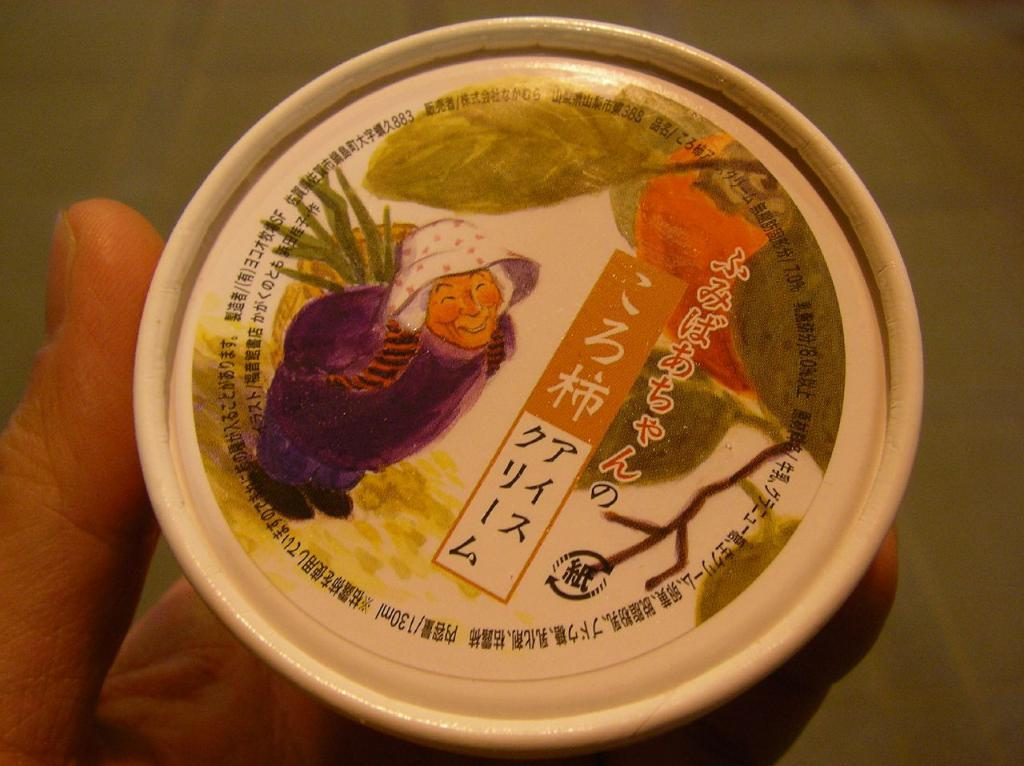What is the person in the image holding? The person is holding a cup in the image. What can be seen on the cup? There is a depiction of a person on the top layer of the cup, and text is visible on the cup. How many houses are visible in the image? There are no houses visible in the image; it features a person holding a cup with a depiction of a person and text on it. 